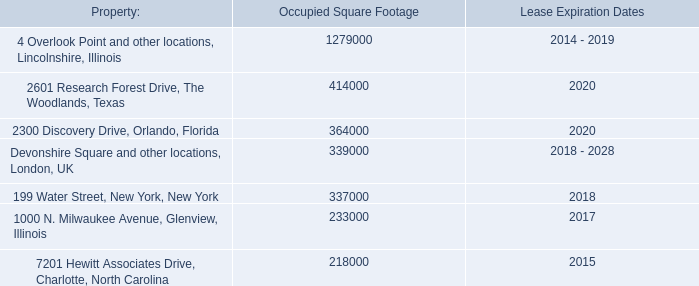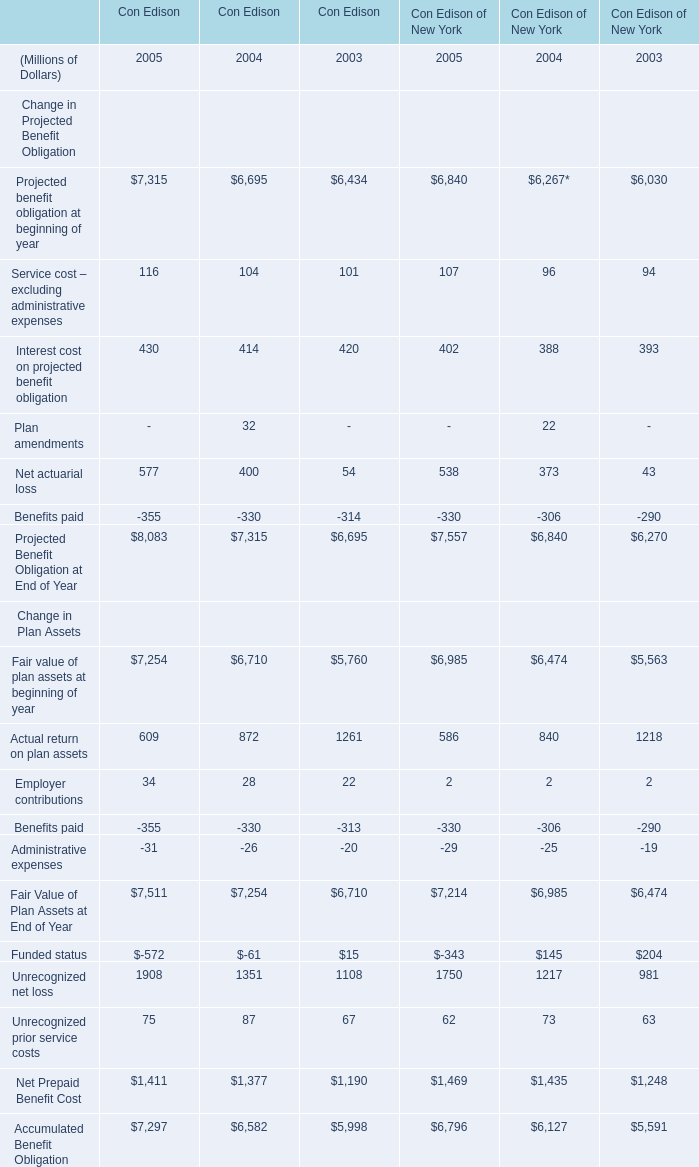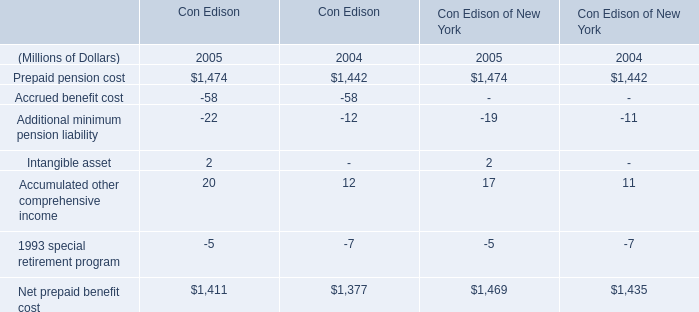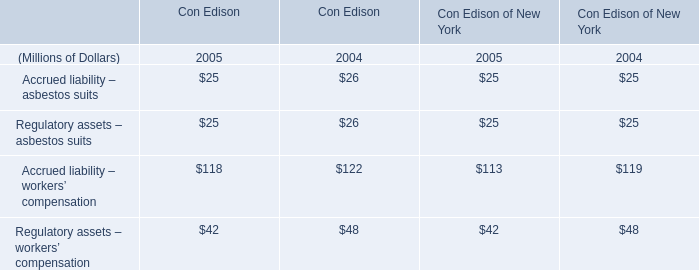What is the sum of 2300 Discovery Drive, Orlando, Florida of Occupied Square Footage, Prepaid pension cost of Con Edison of New York 2004, and Actual return on plan assets Change in Plan Assets of Con Edison of New York 2003 ? 
Computations: ((364000.0 + 1442.0) + 1218.0)
Answer: 366660.0. 